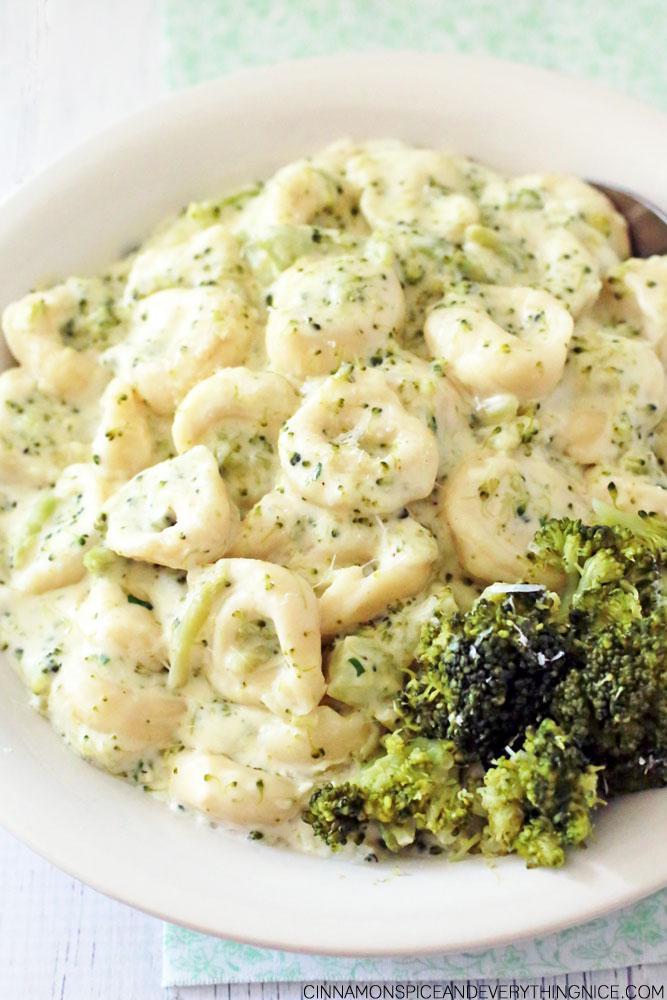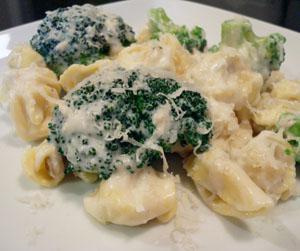The first image is the image on the left, the second image is the image on the right. Examine the images to the left and right. Is the description "The right image contains a fork." accurate? Answer yes or no. No. The first image is the image on the left, the second image is the image on the right. Considering the images on both sides, is "All broccoli dishes are served on white plates." valid? Answer yes or no. Yes. 